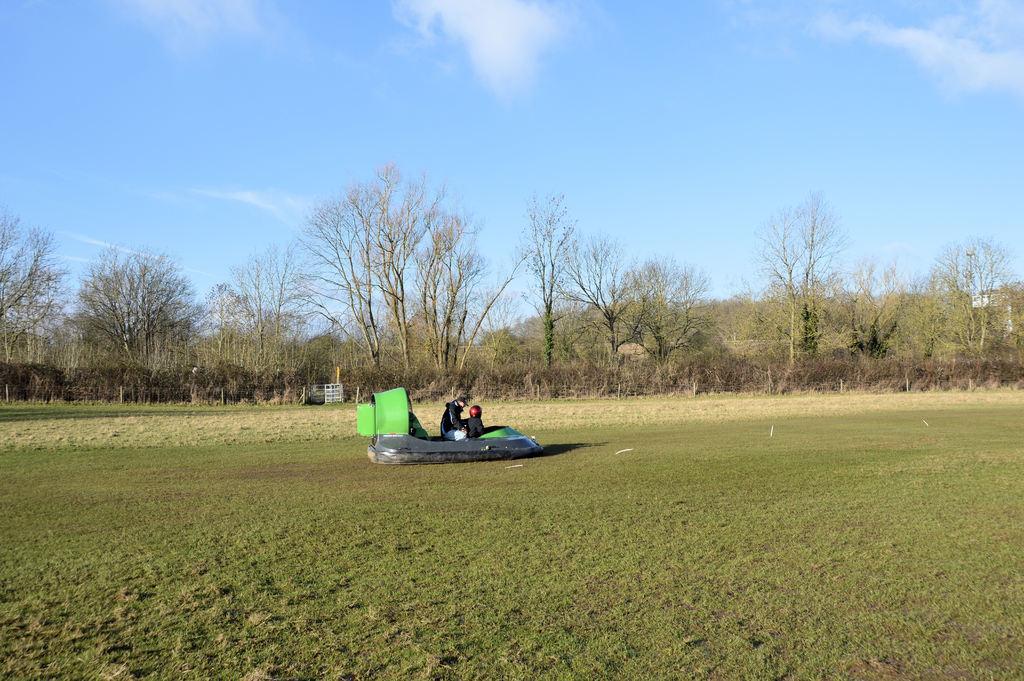Please provide a concise description of this image. In this picture there are two persons sitting on the boat. There is a boat on the grass. At the back there are trees and there is a fence. At the top there is sky and there are clouds. At the bottom there is grass. 